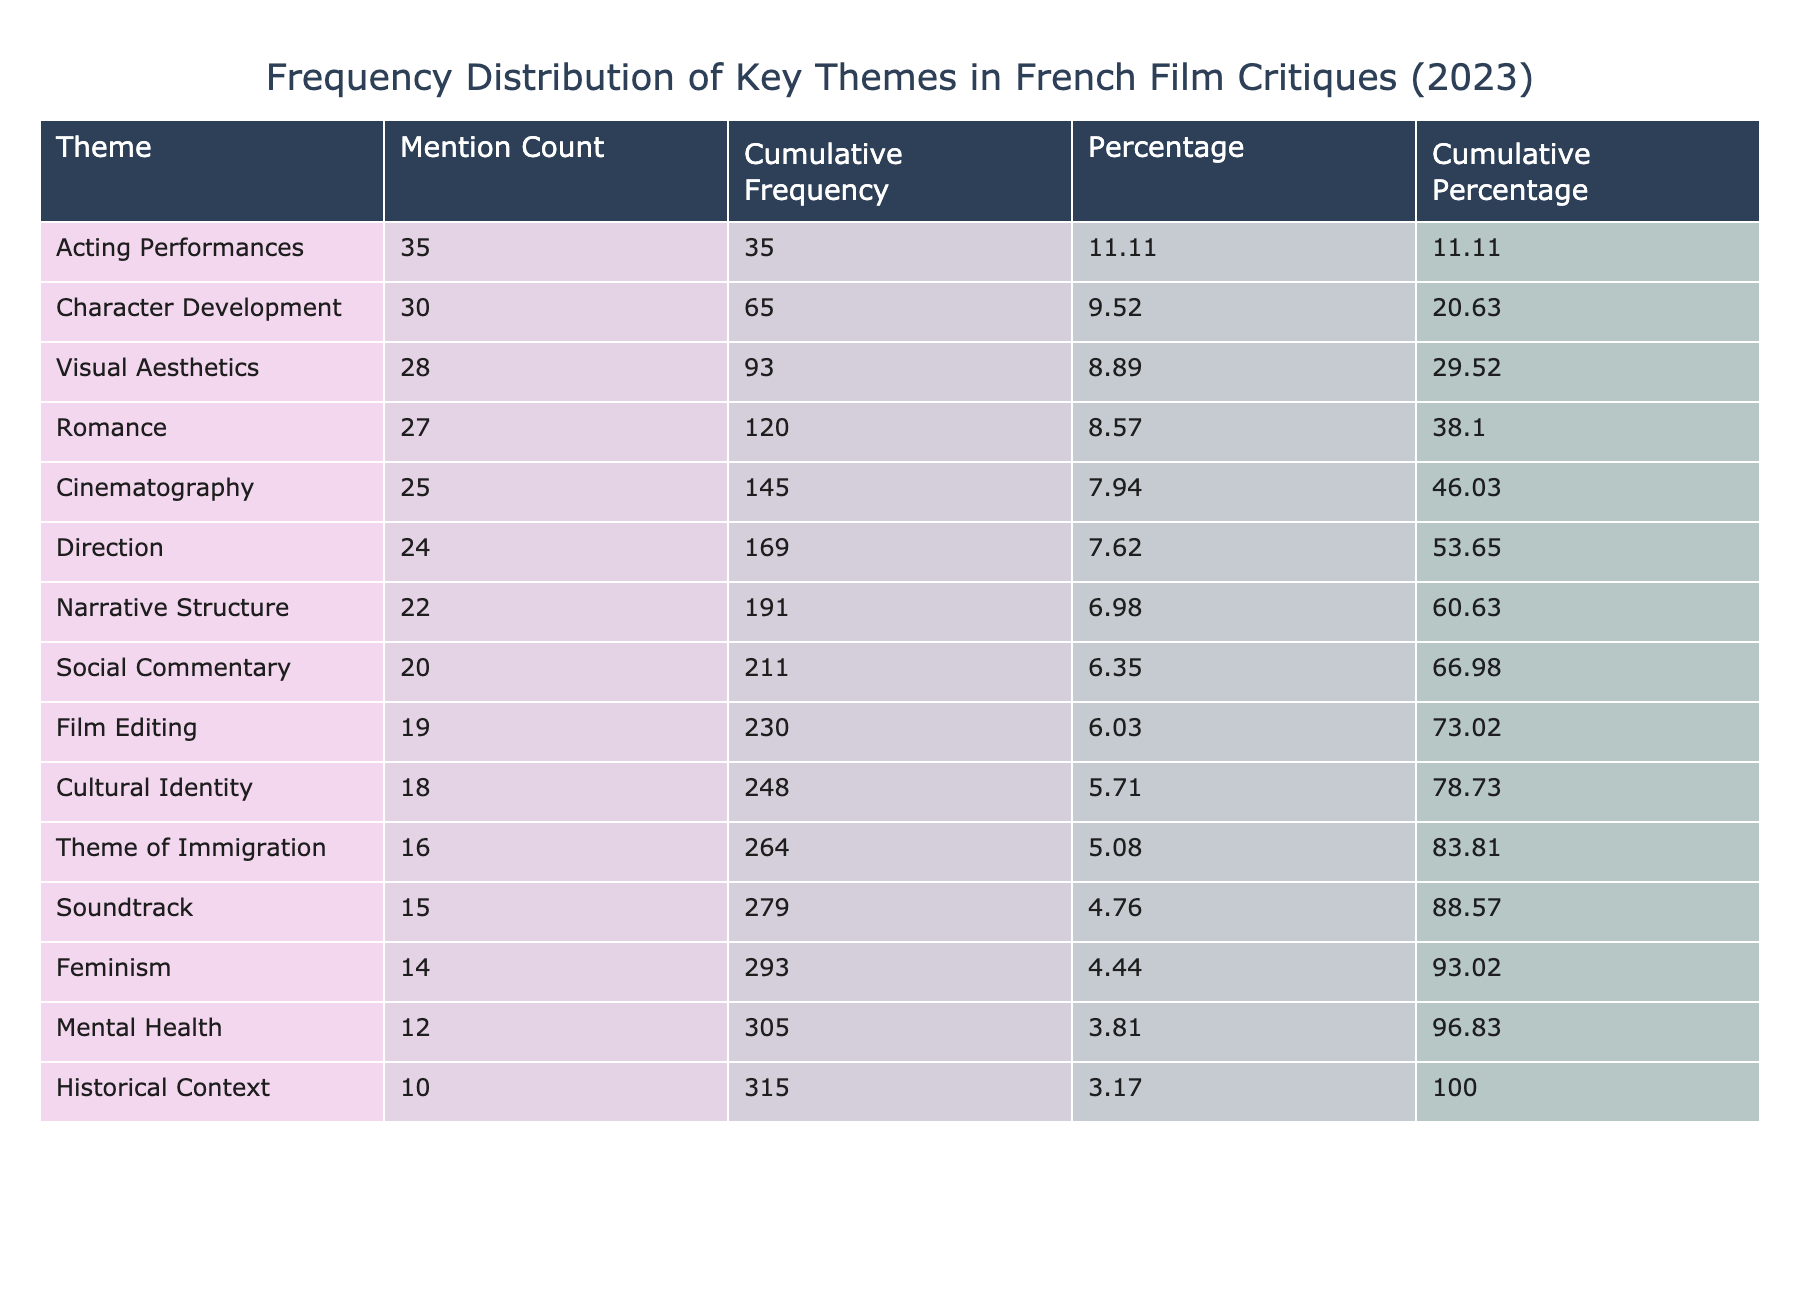What is the mention count for Character Development? The table states that the mention count for Character Development is explicitly listed as 30.
Answer: 30 Which theme has the highest mention count? Analyzing the 'Mention Count' column, we can see that Acting Performances has the highest value at 35.
Answer: Acting Performances What is the cumulative frequency of the theme of Romance? To find the cumulative frequency of Romance, we look for its mention count (27) and note that it accumulates after the preceding themes. The cumulative frequency before Romance (sum of all mention counts preceding it) is 25 (Cinematography) + 30 (Character Development) + 20 (Social Commentary) + 15 (Soundtrack) + 22 (Narrative Structure) + 18 (Cultural Identity) + 28 (Visual Aesthetics) + 24 (Direction), which sums to 172. Adding the mention count of Romance (27) gives 199.
Answer: 199 What is the total mention count for themes that deal with Mental Health and Feminism combined? We first identify the mention counts for the themes: Mental Health has 12 and Feminism has 14. Adding these together results in 12 + 14 = 26.
Answer: 26 Is there a theme related to Cultural Identity that has a higher mention count than Visual Aesthetics? Looking at the mention counts, Cultural Identity has 18 and Visual Aesthetics has 28. Since 18 is less than 28, the statement is false.
Answer: No How many more mentions does Acting Performances have compared to the theme of Soundtrack? For Acting Performances, the mention count is 35 and for Soundtrack, it is 15. The difference can be calculated as 35 - 15 = 20.
Answer: 20 Which themes have a mention count higher than the average mention count? To find the average mention count, we sum all the mention counts (25 + 30 + 20 + 15 + 22 + 18 + 28 + 24 + 35 + 19 + 16 + 27 + 14 + 12 + 10) which equals  25 + 30 + 20 + 15 + 22 + 18 + 28 + 24 + 35 + 19 + 16 + 27 + 14 + 12 + 10 =  314. Dividing this total by the number of themes (15) gives an average of 20.93. The themes with counts higher than this average are: Cinematography (25), Character Development (30), Visual Aesthetics (28), Direction (24), Acting Performances (35), Romance (27).
Answer: Cinematography, Character Development, Visual Aesthetics, Direction, Acting Performances, Romance What percentage of the total mentions does the theme of Social Commentary represent? First, we find the total mention count which is 314. The mention count for Social Commentary is 20. Therefore, the percentage is calculated by (20 / 314) * 100 = 6.37 percent.
Answer: 6.37% 